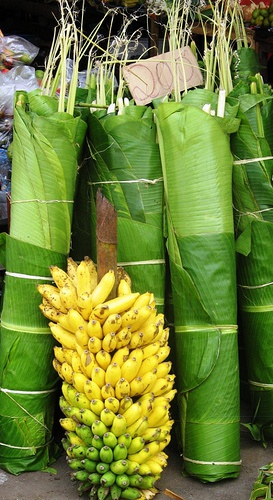Describe the objects in this image and their specific colors. I can see a banana in black, gold, khaki, and olive tones in this image. 